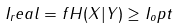Convert formula to latex. <formula><loc_0><loc_0><loc_500><loc_500>I _ { r } e a l = f H ( X | Y ) \geq I _ { o } p t</formula> 